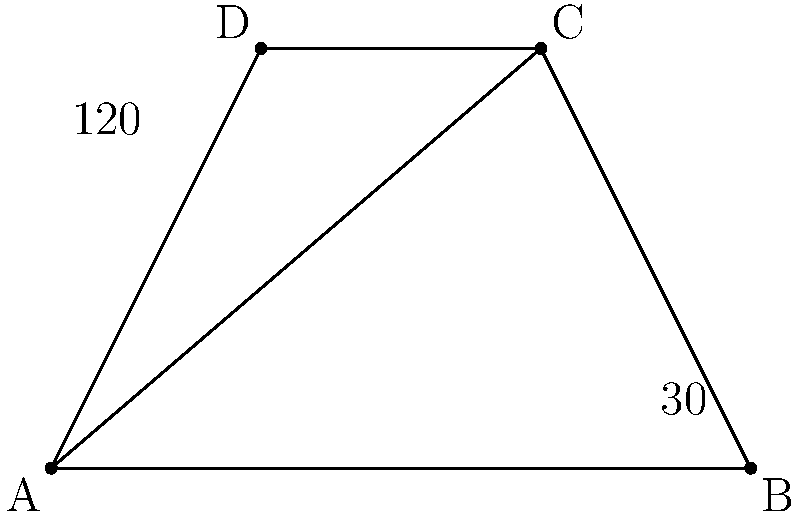In our town's historic district, four streets intersect to form a quadrilateral ABCD as shown. If angle BAC measures 30° and angle ACD measures 120°, what is the measure of angle BCA? Let's approach this step-by-step:

1) In any quadrilateral, the sum of interior angles is 360°.

2) We are given two angles:
   - Angle BAC = 30°
   - Angle ACD = 120°

3) We need to find angle BCA. Let's call this angle x.

4) Notice that angles BAC and BCA form a straight line along AC. In a straight line, angles sum to 180°.

5) Therefore: 
   $30° + x = 180°$

6) Solving for x:
   $x = 180° - 30° = 150°$

7) We can verify this by checking if all angles sum to 360°:
   $30° + 150° + 120° + 60° = 360°$
   (The last angle, CBD, must be 60° to make the sum 360°)

Therefore, angle BCA measures 150°.
Answer: 150° 